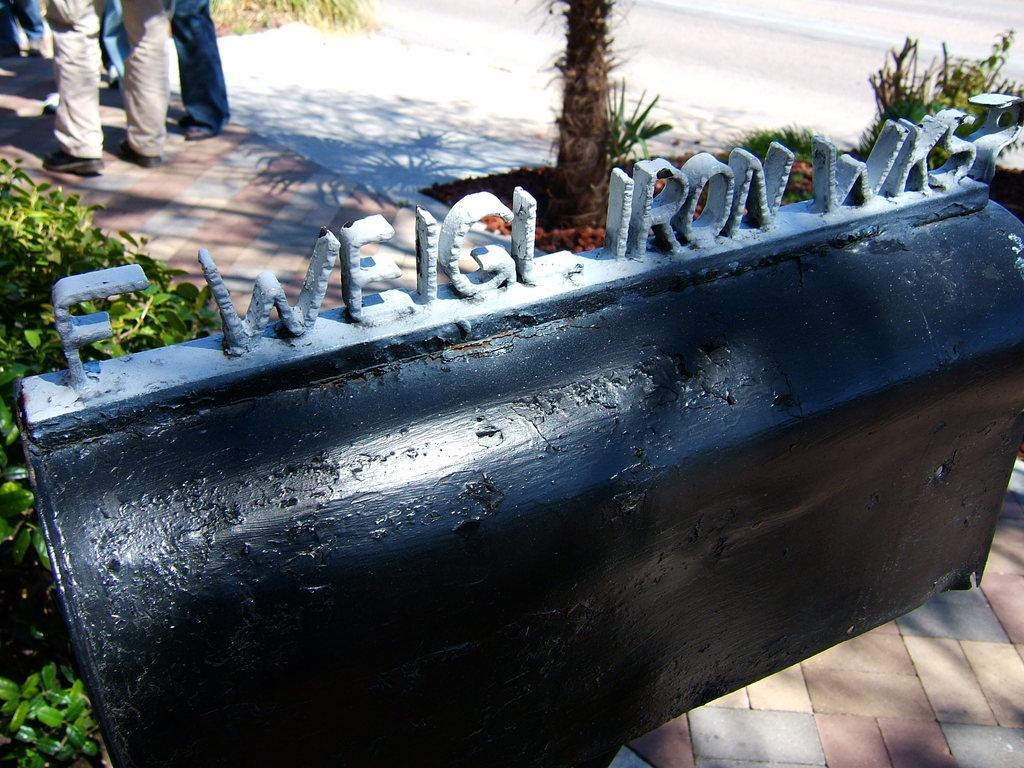Could you give a brief overview of what you see in this image? In this image we can see an iron gate with text on it, bushes, trees and persons standing on the floor. 